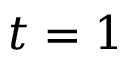<formula> <loc_0><loc_0><loc_500><loc_500>t = 1</formula> 